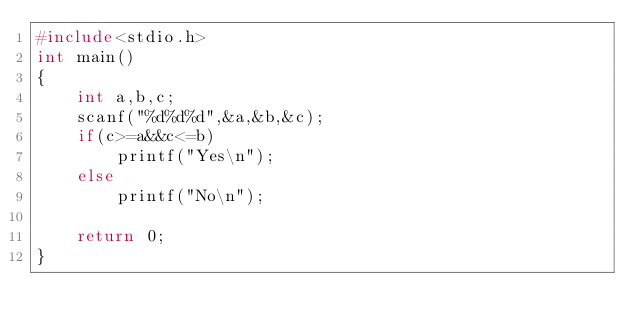Convert code to text. <code><loc_0><loc_0><loc_500><loc_500><_C_>#include<stdio.h>
int main()
{
    int a,b,c;
    scanf("%d%d%d",&a,&b,&c);
    if(c>=a&&c<=b)
        printf("Yes\n");
    else
        printf("No\n");

    return 0;
}
</code> 